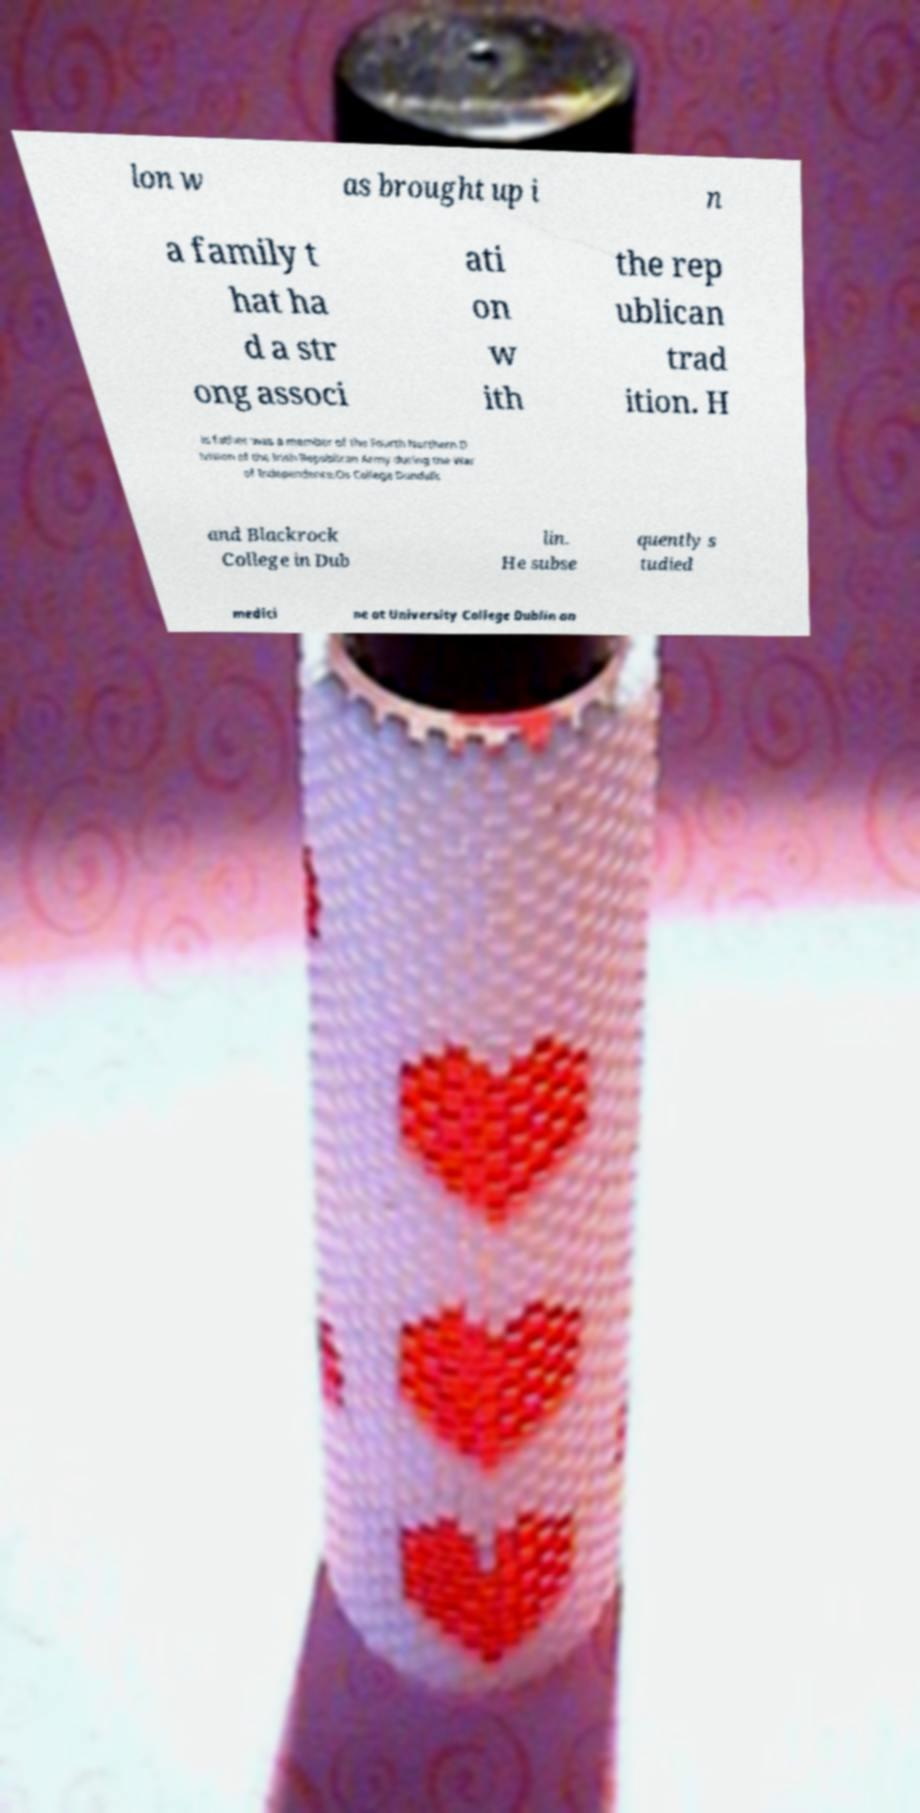Please identify and transcribe the text found in this image. lon w as brought up i n a family t hat ha d a str ong associ ati on w ith the rep ublican trad ition. H is father was a member of the Fourth Northern D ivision of the Irish Republican Army during the War of Independence.Os College Dundalk and Blackrock College in Dub lin. He subse quently s tudied medici ne at University College Dublin an 